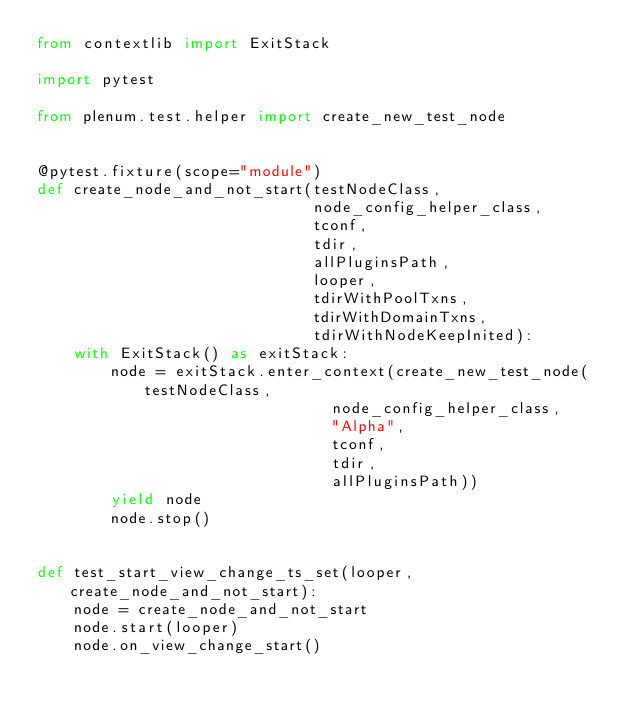Convert code to text. <code><loc_0><loc_0><loc_500><loc_500><_Python_>from contextlib import ExitStack

import pytest

from plenum.test.helper import create_new_test_node


@pytest.fixture(scope="module")
def create_node_and_not_start(testNodeClass,
                              node_config_helper_class,
                              tconf,
                              tdir,
                              allPluginsPath,
                              looper,
                              tdirWithPoolTxns,
                              tdirWithDomainTxns,
                              tdirWithNodeKeepInited):
    with ExitStack() as exitStack:
        node = exitStack.enter_context(create_new_test_node(testNodeClass,
                                node_config_helper_class,
                                "Alpha",
                                tconf,
                                tdir,
                                allPluginsPath))
        yield node
        node.stop()


def test_start_view_change_ts_set(looper, create_node_and_not_start):
    node = create_node_and_not_start
    node.start(looper)
    node.on_view_change_start()</code> 